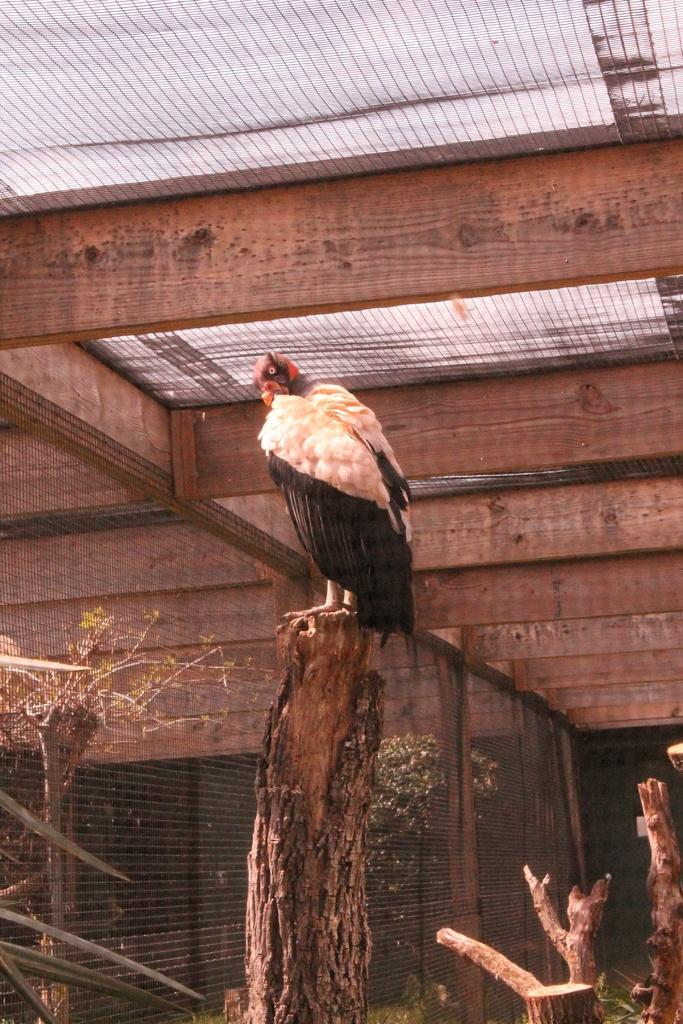What type of animal can be seen in the image? There is a bird in the image. Where is the bird located? The bird is on a tree trunk. What is the background of the image? There are trees in the background of the image. What is the structure visible at the top of the image? There is a roof visible at the top of the image. What can be seen behind the bird? There is a mesh visible behind the bird. Is there a person wearing a mask in the image? There is no person or mask present in the image; it features a bird on a tree trunk with a mesh visible behind it. 